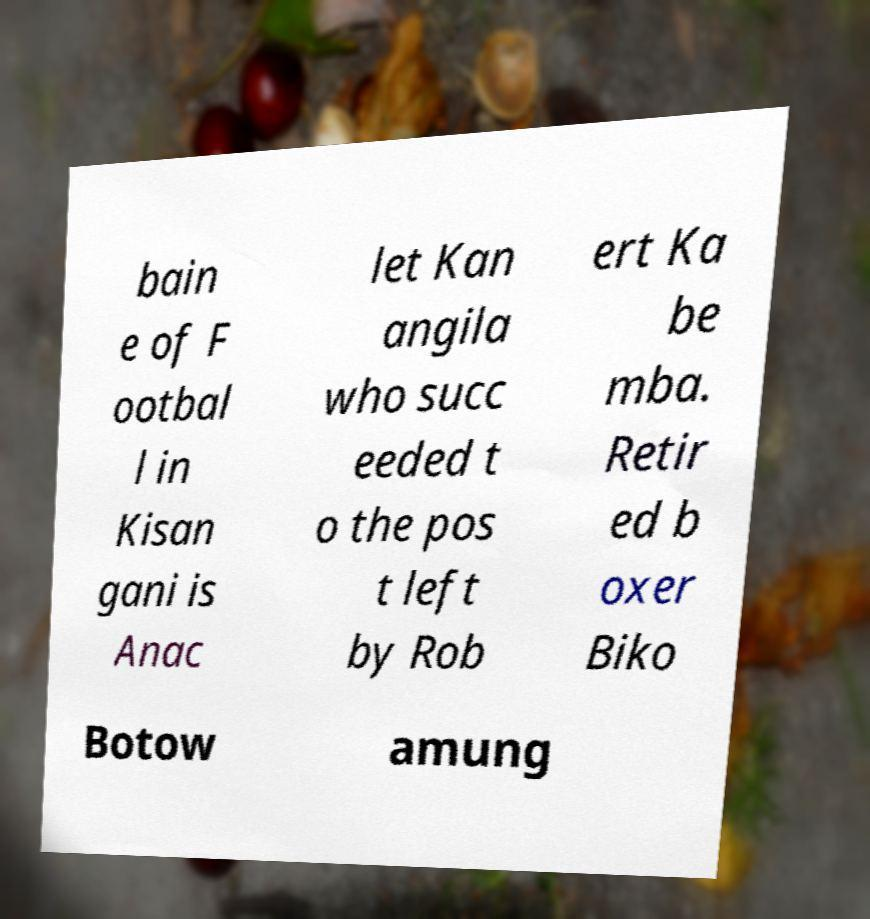For documentation purposes, I need the text within this image transcribed. Could you provide that? bain e of F ootbal l in Kisan gani is Anac let Kan angila who succ eeded t o the pos t left by Rob ert Ka be mba. Retir ed b oxer Biko Botow amung 